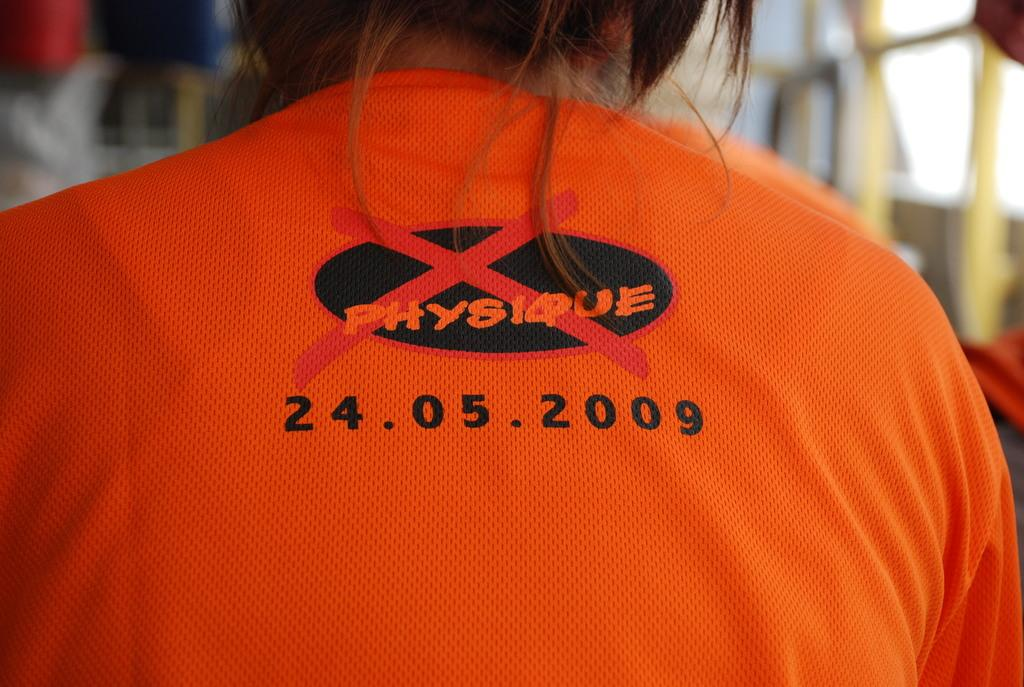Provide a one-sentence caption for the provided image. A back picture of a girl wearing orange shirt with Physique and a date 24.05.2009. 